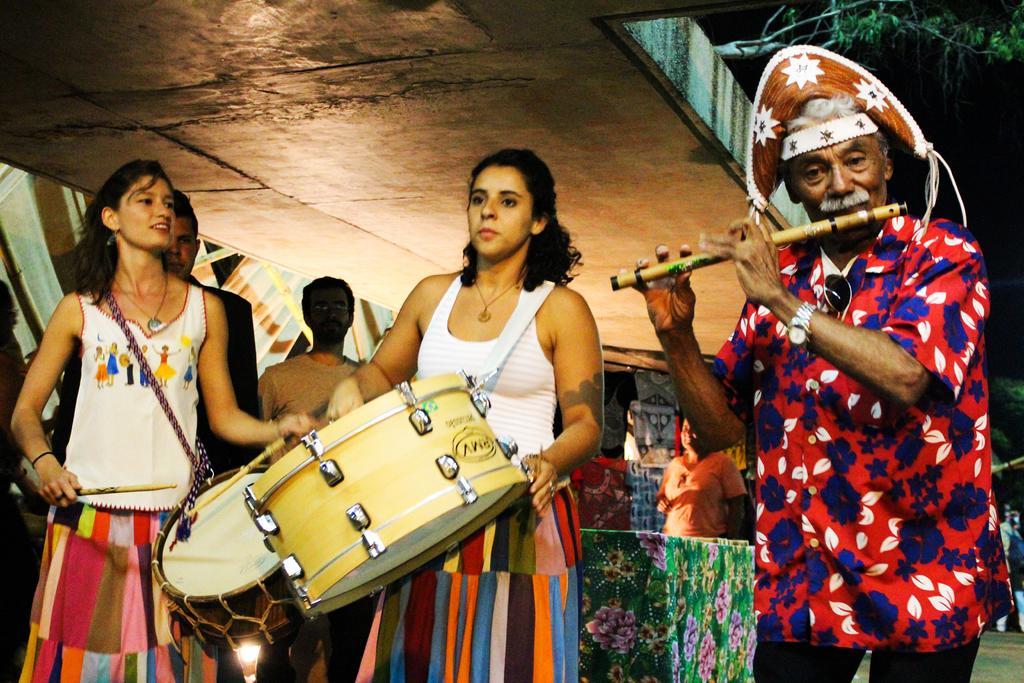Could you give a brief overview of what you see in this image? In this image, in the right side there is a old man standing and he is holding a music instrument which is in yellow color, in the middle there is a woman she is standing and holding a music drum which is in yellow color, in the left side there is a girl standing and she is holding a stick which is in yellow color, in the background there are some people standing, in the top there is a yellow color roof. 